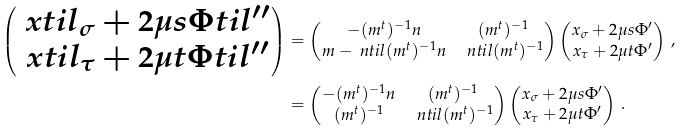Convert formula to latex. <formula><loc_0><loc_0><loc_500><loc_500>\begin{pmatrix} \ x t i l _ { \sigma } + 2 \mu s \Phi t i l ^ { \prime \prime } \\ \ x t i l _ { \tau } + 2 \mu t \Phi t i l ^ { \prime \prime } \end{pmatrix} & = \begin{pmatrix} - ( m ^ { t } ) ^ { - 1 } n & ( m ^ { t } ) ^ { - 1 } \\ m - \ n t i l ( m ^ { t } ) ^ { - 1 } n & \ n t i l ( m ^ { t } ) ^ { - 1 } \end{pmatrix} \begin{pmatrix} x _ { \sigma } + 2 \mu s \Phi ^ { \prime } \\ x _ { \tau } + 2 \mu t \Phi ^ { \prime } \end{pmatrix} \, , \\ & = \begin{pmatrix} - ( m ^ { t } ) ^ { - 1 } n & ( m ^ { t } ) ^ { - 1 } \\ ( m ^ { t } ) ^ { - 1 } & \ n t i l ( m ^ { t } ) ^ { - 1 } \end{pmatrix} \begin{pmatrix} x _ { \sigma } + 2 \mu s \Phi ^ { \prime } \\ x _ { \tau } + 2 \mu t \Phi ^ { \prime } \end{pmatrix} \, .</formula> 